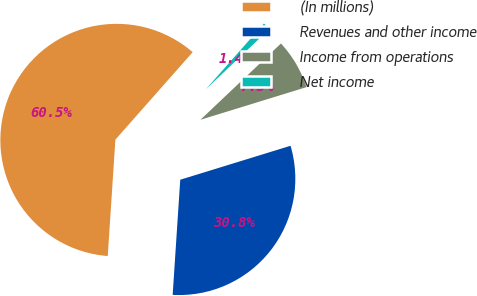Convert chart to OTSL. <chart><loc_0><loc_0><loc_500><loc_500><pie_chart><fcel>(In millions)<fcel>Revenues and other income<fcel>Income from operations<fcel>Net income<nl><fcel>60.47%<fcel>30.8%<fcel>7.32%<fcel>1.41%<nl></chart> 